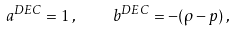<formula> <loc_0><loc_0><loc_500><loc_500>a ^ { D E C } = 1 \, , \quad b ^ { D E C } = - ( \rho - p ) \, ,</formula> 